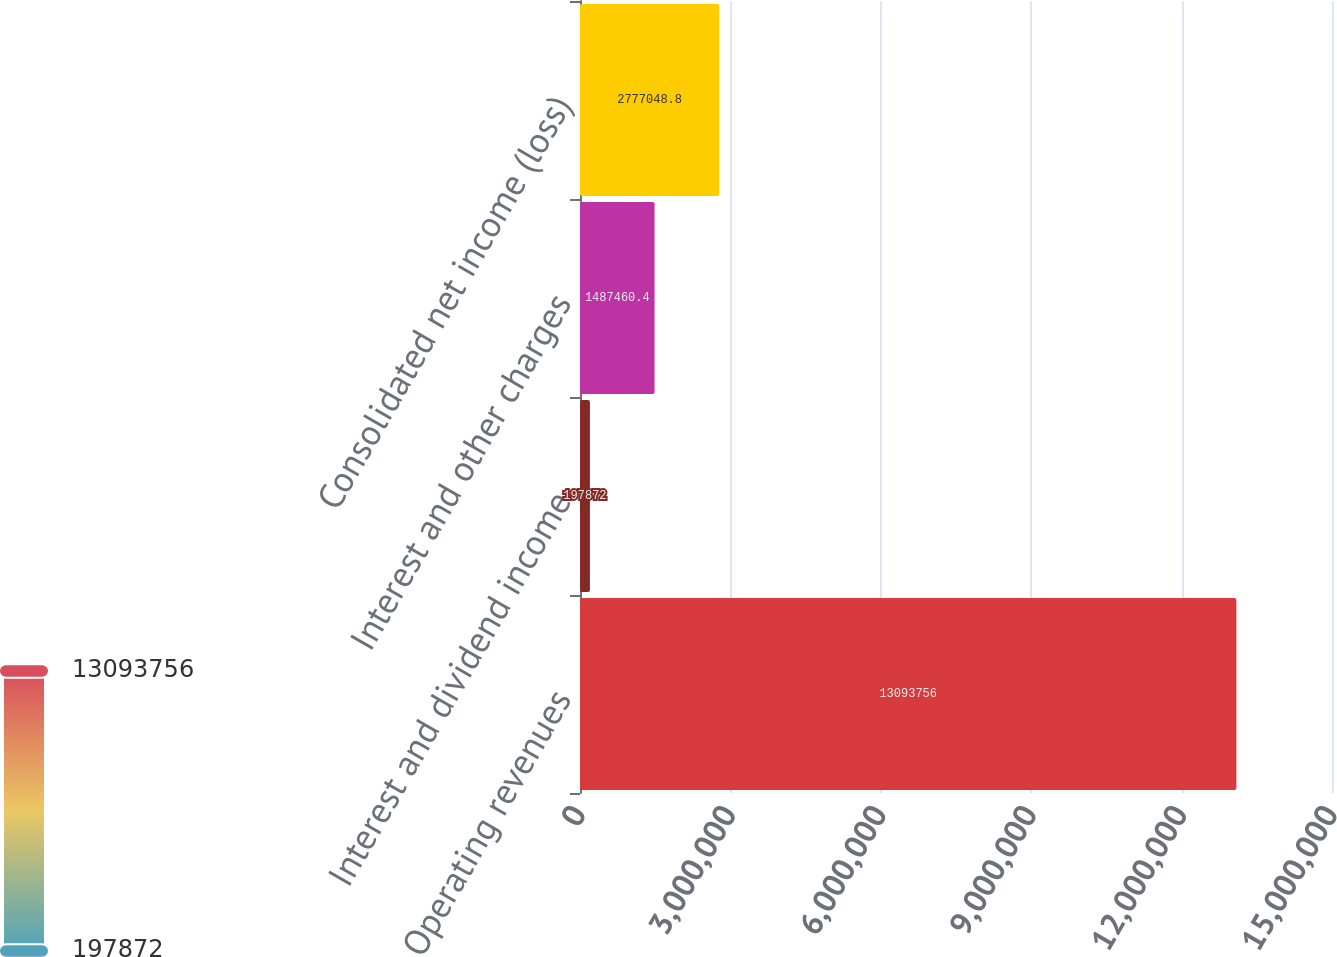Convert chart to OTSL. <chart><loc_0><loc_0><loc_500><loc_500><bar_chart><fcel>Operating revenues<fcel>Interest and dividend income<fcel>Interest and other charges<fcel>Consolidated net income (loss)<nl><fcel>1.30938e+07<fcel>197872<fcel>1.48746e+06<fcel>2.77705e+06<nl></chart> 